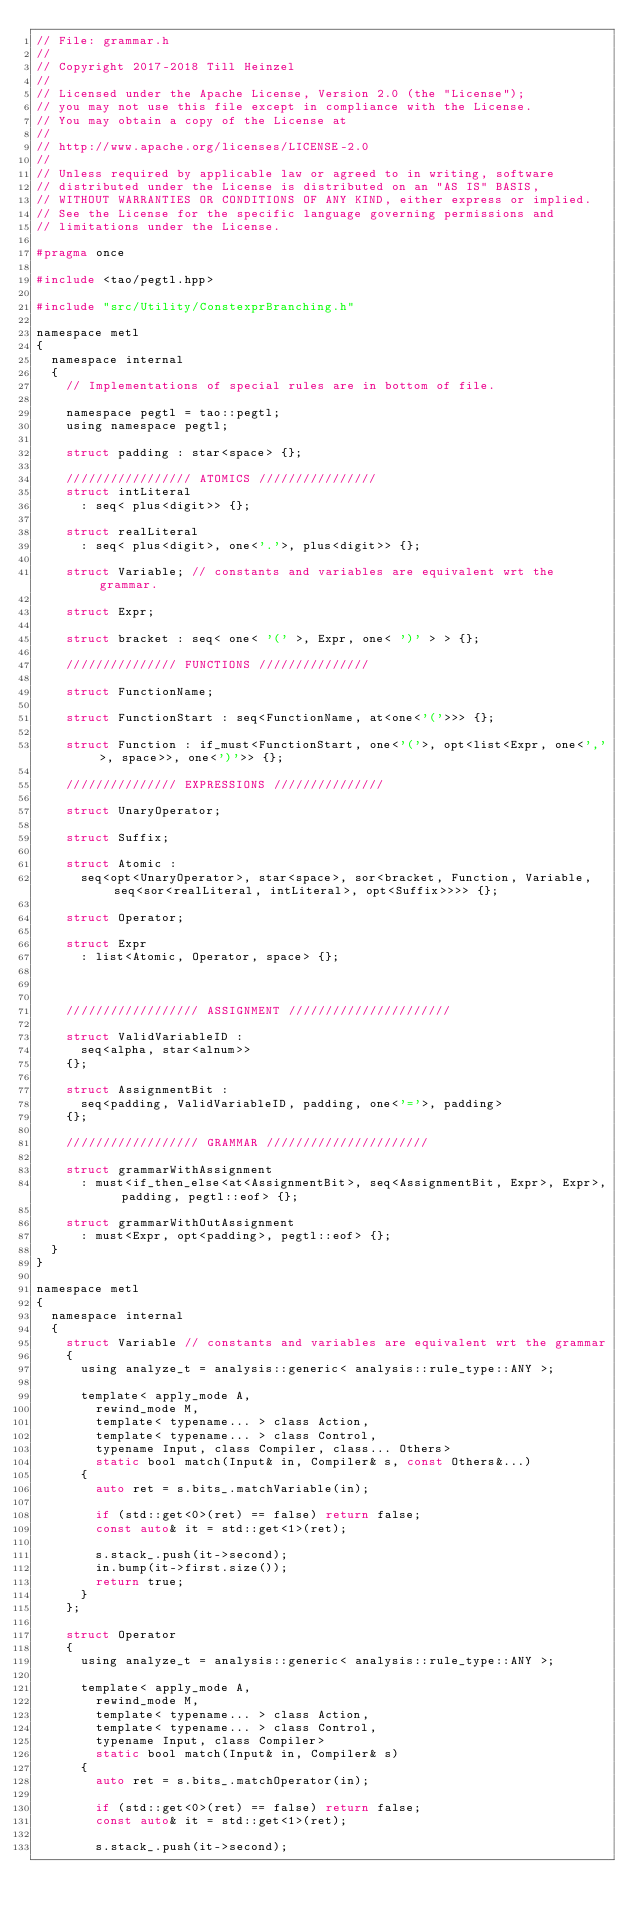<code> <loc_0><loc_0><loc_500><loc_500><_C_>// File: grammar.h
// 
// Copyright 2017-2018 Till Heinzel
// 
// Licensed under the Apache License, Version 2.0 (the "License");
// you may not use this file except in compliance with the License.
// You may obtain a copy of the License at
// 
// http://www.apache.org/licenses/LICENSE-2.0
// 
// Unless required by applicable law or agreed to in writing, software
// distributed under the License is distributed on an "AS IS" BASIS,
// WITHOUT WARRANTIES OR CONDITIONS OF ANY KIND, either express or implied.
// See the License for the specific language governing permissions and
// limitations under the License.

#pragma once

#include <tao/pegtl.hpp>

#include "src/Utility/ConstexprBranching.h"

namespace metl
{
	namespace internal
	{
		// Implementations of special rules are in bottom of file.

		namespace pegtl = tao::pegtl;
		using namespace pegtl;

		struct padding : star<space> {};

		///////////////// ATOMICS ////////////////
		struct intLiteral
			: seq< plus<digit>> {};

		struct realLiteral
			: seq< plus<digit>, one<'.'>, plus<digit>> {};

		struct Variable; // constants and variables are equivalent wrt the grammar. 

		struct Expr;

		struct bracket : seq< one< '(' >, Expr, one< ')' > > {};

		/////////////// FUNCTIONS ///////////////

		struct FunctionName;

		struct FunctionStart : seq<FunctionName, at<one<'('>>> {};

		struct Function : if_must<FunctionStart, one<'('>, opt<list<Expr, one<','>, space>>, one<')'>> {};

		/////////////// EXPRESSIONS ///////////////

		struct UnaryOperator;

		struct Suffix;

		struct Atomic :
			seq<opt<UnaryOperator>, star<space>, sor<bracket, Function, Variable, seq<sor<realLiteral, intLiteral>, opt<Suffix>>>> {};

		struct Operator;

		struct Expr
			: list<Atomic, Operator, space> {};



		////////////////// ASSIGNMENT //////////////////////

		struct ValidVariableID :
			seq<alpha, star<alnum>>
		{};

		struct AssignmentBit :
			seq<padding, ValidVariableID, padding, one<'='>, padding>
		{};

		////////////////// GRAMMAR //////////////////////

		struct grammarWithAssignment
			: must<if_then_else<at<AssignmentBit>, seq<AssignmentBit, Expr>, Expr>, padding, pegtl::eof> {};

		struct grammarWithOutAssignment
			: must<Expr, opt<padding>, pegtl::eof> {};
	}
}

namespace metl
{
	namespace internal
	{
		struct Variable // constants and variables are equivalent wrt the grammar
		{
			using analyze_t = analysis::generic< analysis::rule_type::ANY >;

			template< apply_mode A,
				rewind_mode M,
				template< typename... > class Action,
				template< typename... > class Control,
				typename Input, class Compiler, class... Others>
				static bool match(Input& in, Compiler& s, const Others&...)
			{
				auto ret = s.bits_.matchVariable(in);

				if (std::get<0>(ret) == false) return false;
				const auto& it = std::get<1>(ret);

				s.stack_.push(it->second);
				in.bump(it->first.size());
				return true;
			}
		};

		struct Operator
		{
			using analyze_t = analysis::generic< analysis::rule_type::ANY >;

			template< apply_mode A,
				rewind_mode M,
				template< typename... > class Action,
				template< typename... > class Control,
				typename Input, class Compiler>
				static bool match(Input& in, Compiler& s)
			{
				auto ret = s.bits_.matchOperator(in);

				if (std::get<0>(ret) == false) return false;
				const auto& it = std::get<1>(ret);

				s.stack_.push(it->second);</code> 